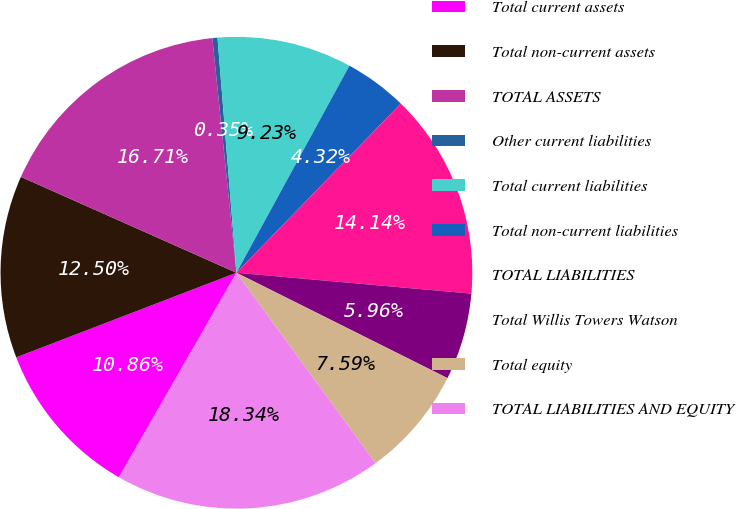<chart> <loc_0><loc_0><loc_500><loc_500><pie_chart><fcel>Total current assets<fcel>Total non-current assets<fcel>TOTAL ASSETS<fcel>Other current liabilities<fcel>Total current liabilities<fcel>Total non-current liabilities<fcel>TOTAL LIABILITIES<fcel>Total Willis Towers Watson<fcel>Total equity<fcel>TOTAL LIABILITIES AND EQUITY<nl><fcel>10.86%<fcel>12.5%<fcel>16.71%<fcel>0.35%<fcel>9.23%<fcel>4.32%<fcel>14.14%<fcel>5.96%<fcel>7.59%<fcel>18.34%<nl></chart> 